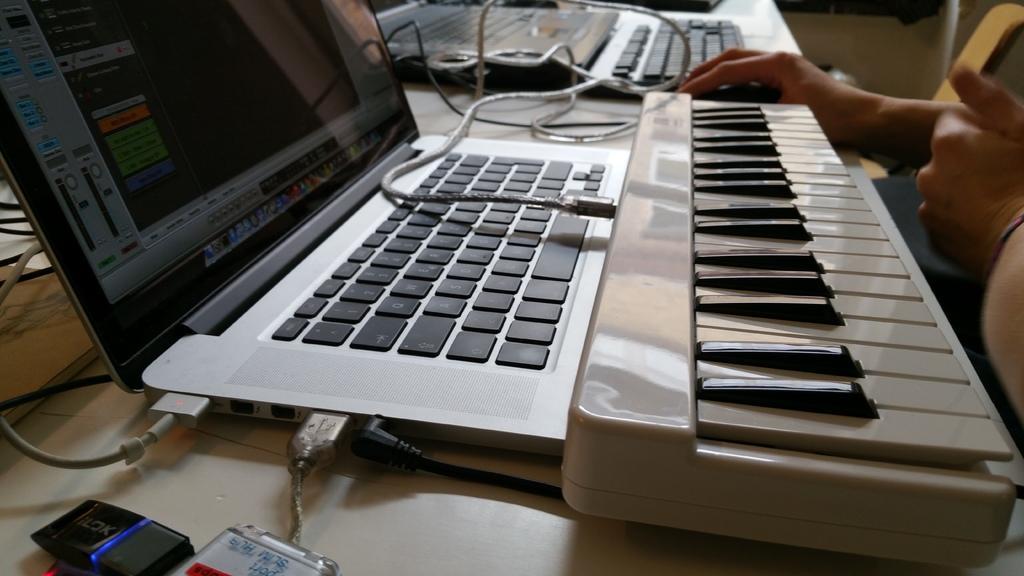How would you summarize this image in a sentence or two? In the middle there is a laptop. On the right side there is a piano in white color. 